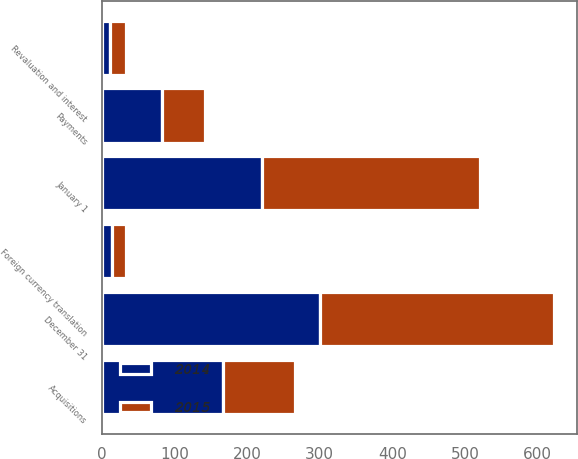Convert chart. <chart><loc_0><loc_0><loc_500><loc_500><stacked_bar_chart><ecel><fcel>January 1<fcel>Acquisitions<fcel>Revaluation and interest<fcel>Payments<fcel>Foreign currency translation<fcel>December 31<nl><fcel>2015<fcel>300.7<fcel>98.9<fcel>21.8<fcel>58.6<fcel>19.4<fcel>322<nl><fcel>2014<fcel>220.2<fcel>167.1<fcel>11<fcel>83.2<fcel>14.4<fcel>300.7<nl></chart> 